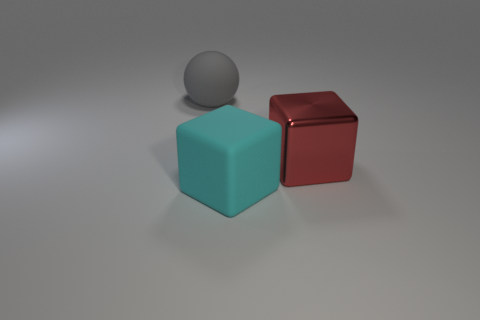Is there a small blue cylinder?
Ensure brevity in your answer.  No. Are there any other things that have the same shape as the gray matte thing?
Your answer should be compact. No. Is the number of shiny objects that are in front of the ball greater than the number of small yellow rubber blocks?
Provide a succinct answer. Yes. Are there any big cubes in front of the metal thing?
Provide a succinct answer. Yes. Do the metallic block and the cyan matte block have the same size?
Offer a terse response. Yes. What size is the other object that is the same shape as the red thing?
Keep it short and to the point. Large. Are there any other things that have the same size as the shiny object?
Give a very brief answer. Yes. The object that is behind the cube behind the big rubber cube is made of what material?
Offer a very short reply. Rubber. Is the cyan thing the same shape as the large gray matte object?
Provide a short and direct response. No. How many big things are both behind the cyan matte thing and to the right of the rubber ball?
Offer a very short reply. 1. 